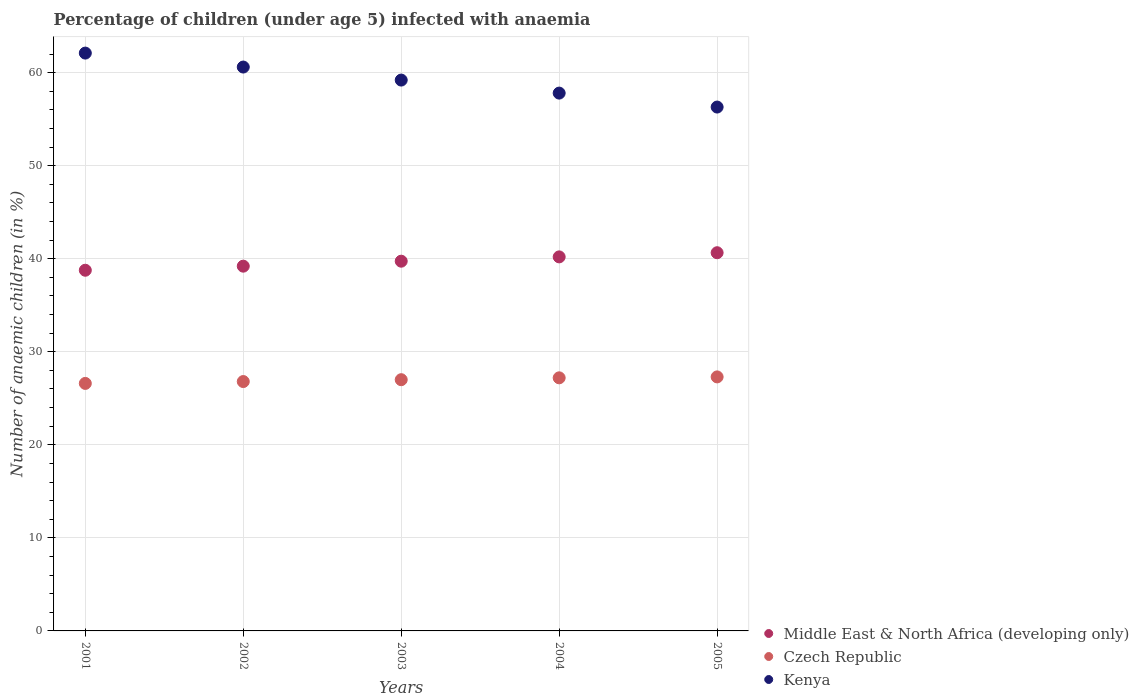Is the number of dotlines equal to the number of legend labels?
Provide a short and direct response. Yes. What is the percentage of children infected with anaemia in in Middle East & North Africa (developing only) in 2003?
Keep it short and to the point. 39.74. Across all years, what is the maximum percentage of children infected with anaemia in in Middle East & North Africa (developing only)?
Your response must be concise. 40.65. Across all years, what is the minimum percentage of children infected with anaemia in in Kenya?
Provide a short and direct response. 56.3. In which year was the percentage of children infected with anaemia in in Kenya minimum?
Provide a succinct answer. 2005. What is the total percentage of children infected with anaemia in in Middle East & North Africa (developing only) in the graph?
Make the answer very short. 198.54. What is the difference between the percentage of children infected with anaemia in in Czech Republic in 2001 and that in 2003?
Give a very brief answer. -0.4. What is the difference between the percentage of children infected with anaemia in in Kenya in 2002 and the percentage of children infected with anaemia in in Middle East & North Africa (developing only) in 2005?
Keep it short and to the point. 19.95. What is the average percentage of children infected with anaemia in in Czech Republic per year?
Offer a terse response. 26.98. In the year 2002, what is the difference between the percentage of children infected with anaemia in in Czech Republic and percentage of children infected with anaemia in in Middle East & North Africa (developing only)?
Provide a short and direct response. -12.4. In how many years, is the percentage of children infected with anaemia in in Czech Republic greater than 14 %?
Make the answer very short. 5. What is the ratio of the percentage of children infected with anaemia in in Middle East & North Africa (developing only) in 2002 to that in 2004?
Your answer should be very brief. 0.98. Is the percentage of children infected with anaemia in in Middle East & North Africa (developing only) in 2001 less than that in 2003?
Your answer should be compact. Yes. Is the difference between the percentage of children infected with anaemia in in Czech Republic in 2001 and 2004 greater than the difference between the percentage of children infected with anaemia in in Middle East & North Africa (developing only) in 2001 and 2004?
Provide a short and direct response. Yes. What is the difference between the highest and the second highest percentage of children infected with anaemia in in Czech Republic?
Give a very brief answer. 0.1. What is the difference between the highest and the lowest percentage of children infected with anaemia in in Middle East & North Africa (developing only)?
Your answer should be very brief. 1.88. In how many years, is the percentage of children infected with anaemia in in Middle East & North Africa (developing only) greater than the average percentage of children infected with anaemia in in Middle East & North Africa (developing only) taken over all years?
Ensure brevity in your answer.  3. Is the sum of the percentage of children infected with anaemia in in Middle East & North Africa (developing only) in 2002 and 2005 greater than the maximum percentage of children infected with anaemia in in Kenya across all years?
Provide a succinct answer. Yes. Does the percentage of children infected with anaemia in in Kenya monotonically increase over the years?
Offer a terse response. No. Is the percentage of children infected with anaemia in in Kenya strictly less than the percentage of children infected with anaemia in in Middle East & North Africa (developing only) over the years?
Your answer should be compact. No. How many years are there in the graph?
Offer a very short reply. 5. What is the difference between two consecutive major ticks on the Y-axis?
Offer a very short reply. 10. Does the graph contain any zero values?
Ensure brevity in your answer.  No. Does the graph contain grids?
Your response must be concise. Yes. Where does the legend appear in the graph?
Keep it short and to the point. Bottom right. How many legend labels are there?
Your response must be concise. 3. How are the legend labels stacked?
Your answer should be very brief. Vertical. What is the title of the graph?
Your answer should be compact. Percentage of children (under age 5) infected with anaemia. What is the label or title of the Y-axis?
Offer a very short reply. Number of anaemic children (in %). What is the Number of anaemic children (in %) of Middle East & North Africa (developing only) in 2001?
Your answer should be very brief. 38.76. What is the Number of anaemic children (in %) in Czech Republic in 2001?
Keep it short and to the point. 26.6. What is the Number of anaemic children (in %) in Kenya in 2001?
Your answer should be very brief. 62.1. What is the Number of anaemic children (in %) in Middle East & North Africa (developing only) in 2002?
Provide a short and direct response. 39.2. What is the Number of anaemic children (in %) of Czech Republic in 2002?
Your answer should be very brief. 26.8. What is the Number of anaemic children (in %) in Kenya in 2002?
Your answer should be very brief. 60.6. What is the Number of anaemic children (in %) of Middle East & North Africa (developing only) in 2003?
Provide a succinct answer. 39.74. What is the Number of anaemic children (in %) of Czech Republic in 2003?
Provide a succinct answer. 27. What is the Number of anaemic children (in %) of Kenya in 2003?
Keep it short and to the point. 59.2. What is the Number of anaemic children (in %) in Middle East & North Africa (developing only) in 2004?
Ensure brevity in your answer.  40.2. What is the Number of anaemic children (in %) of Czech Republic in 2004?
Provide a short and direct response. 27.2. What is the Number of anaemic children (in %) in Kenya in 2004?
Ensure brevity in your answer.  57.8. What is the Number of anaemic children (in %) of Middle East & North Africa (developing only) in 2005?
Provide a short and direct response. 40.65. What is the Number of anaemic children (in %) of Czech Republic in 2005?
Your answer should be compact. 27.3. What is the Number of anaemic children (in %) of Kenya in 2005?
Your response must be concise. 56.3. Across all years, what is the maximum Number of anaemic children (in %) of Middle East & North Africa (developing only)?
Provide a short and direct response. 40.65. Across all years, what is the maximum Number of anaemic children (in %) of Czech Republic?
Your answer should be compact. 27.3. Across all years, what is the maximum Number of anaemic children (in %) in Kenya?
Make the answer very short. 62.1. Across all years, what is the minimum Number of anaemic children (in %) of Middle East & North Africa (developing only)?
Keep it short and to the point. 38.76. Across all years, what is the minimum Number of anaemic children (in %) of Czech Republic?
Offer a very short reply. 26.6. Across all years, what is the minimum Number of anaemic children (in %) of Kenya?
Provide a succinct answer. 56.3. What is the total Number of anaemic children (in %) of Middle East & North Africa (developing only) in the graph?
Make the answer very short. 198.54. What is the total Number of anaemic children (in %) of Czech Republic in the graph?
Give a very brief answer. 134.9. What is the total Number of anaemic children (in %) in Kenya in the graph?
Ensure brevity in your answer.  296. What is the difference between the Number of anaemic children (in %) in Middle East & North Africa (developing only) in 2001 and that in 2002?
Offer a very short reply. -0.44. What is the difference between the Number of anaemic children (in %) of Kenya in 2001 and that in 2002?
Your answer should be compact. 1.5. What is the difference between the Number of anaemic children (in %) of Middle East & North Africa (developing only) in 2001 and that in 2003?
Provide a succinct answer. -0.97. What is the difference between the Number of anaemic children (in %) in Czech Republic in 2001 and that in 2003?
Provide a succinct answer. -0.4. What is the difference between the Number of anaemic children (in %) in Kenya in 2001 and that in 2003?
Ensure brevity in your answer.  2.9. What is the difference between the Number of anaemic children (in %) in Middle East & North Africa (developing only) in 2001 and that in 2004?
Your answer should be very brief. -1.44. What is the difference between the Number of anaemic children (in %) in Czech Republic in 2001 and that in 2004?
Provide a succinct answer. -0.6. What is the difference between the Number of anaemic children (in %) of Middle East & North Africa (developing only) in 2001 and that in 2005?
Offer a very short reply. -1.88. What is the difference between the Number of anaemic children (in %) of Czech Republic in 2001 and that in 2005?
Keep it short and to the point. -0.7. What is the difference between the Number of anaemic children (in %) in Kenya in 2001 and that in 2005?
Make the answer very short. 5.8. What is the difference between the Number of anaemic children (in %) in Middle East & North Africa (developing only) in 2002 and that in 2003?
Offer a terse response. -0.53. What is the difference between the Number of anaemic children (in %) of Middle East & North Africa (developing only) in 2002 and that in 2004?
Your answer should be very brief. -1. What is the difference between the Number of anaemic children (in %) of Czech Republic in 2002 and that in 2004?
Offer a very short reply. -0.4. What is the difference between the Number of anaemic children (in %) in Middle East & North Africa (developing only) in 2002 and that in 2005?
Give a very brief answer. -1.45. What is the difference between the Number of anaemic children (in %) in Middle East & North Africa (developing only) in 2003 and that in 2004?
Your response must be concise. -0.46. What is the difference between the Number of anaemic children (in %) of Czech Republic in 2003 and that in 2004?
Your answer should be very brief. -0.2. What is the difference between the Number of anaemic children (in %) in Middle East & North Africa (developing only) in 2003 and that in 2005?
Your response must be concise. -0.91. What is the difference between the Number of anaemic children (in %) in Kenya in 2003 and that in 2005?
Your answer should be very brief. 2.9. What is the difference between the Number of anaemic children (in %) of Middle East & North Africa (developing only) in 2004 and that in 2005?
Offer a terse response. -0.45. What is the difference between the Number of anaemic children (in %) of Middle East & North Africa (developing only) in 2001 and the Number of anaemic children (in %) of Czech Republic in 2002?
Your answer should be compact. 11.96. What is the difference between the Number of anaemic children (in %) in Middle East & North Africa (developing only) in 2001 and the Number of anaemic children (in %) in Kenya in 2002?
Ensure brevity in your answer.  -21.84. What is the difference between the Number of anaemic children (in %) in Czech Republic in 2001 and the Number of anaemic children (in %) in Kenya in 2002?
Give a very brief answer. -34. What is the difference between the Number of anaemic children (in %) in Middle East & North Africa (developing only) in 2001 and the Number of anaemic children (in %) in Czech Republic in 2003?
Your answer should be very brief. 11.76. What is the difference between the Number of anaemic children (in %) of Middle East & North Africa (developing only) in 2001 and the Number of anaemic children (in %) of Kenya in 2003?
Offer a very short reply. -20.44. What is the difference between the Number of anaemic children (in %) of Czech Republic in 2001 and the Number of anaemic children (in %) of Kenya in 2003?
Your response must be concise. -32.6. What is the difference between the Number of anaemic children (in %) of Middle East & North Africa (developing only) in 2001 and the Number of anaemic children (in %) of Czech Republic in 2004?
Offer a terse response. 11.56. What is the difference between the Number of anaemic children (in %) in Middle East & North Africa (developing only) in 2001 and the Number of anaemic children (in %) in Kenya in 2004?
Your answer should be very brief. -19.04. What is the difference between the Number of anaemic children (in %) in Czech Republic in 2001 and the Number of anaemic children (in %) in Kenya in 2004?
Provide a short and direct response. -31.2. What is the difference between the Number of anaemic children (in %) in Middle East & North Africa (developing only) in 2001 and the Number of anaemic children (in %) in Czech Republic in 2005?
Keep it short and to the point. 11.46. What is the difference between the Number of anaemic children (in %) of Middle East & North Africa (developing only) in 2001 and the Number of anaemic children (in %) of Kenya in 2005?
Provide a short and direct response. -17.54. What is the difference between the Number of anaemic children (in %) of Czech Republic in 2001 and the Number of anaemic children (in %) of Kenya in 2005?
Offer a terse response. -29.7. What is the difference between the Number of anaemic children (in %) of Middle East & North Africa (developing only) in 2002 and the Number of anaemic children (in %) of Czech Republic in 2003?
Offer a terse response. 12.2. What is the difference between the Number of anaemic children (in %) of Middle East & North Africa (developing only) in 2002 and the Number of anaemic children (in %) of Kenya in 2003?
Keep it short and to the point. -20. What is the difference between the Number of anaemic children (in %) of Czech Republic in 2002 and the Number of anaemic children (in %) of Kenya in 2003?
Ensure brevity in your answer.  -32.4. What is the difference between the Number of anaemic children (in %) of Middle East & North Africa (developing only) in 2002 and the Number of anaemic children (in %) of Czech Republic in 2004?
Give a very brief answer. 12. What is the difference between the Number of anaemic children (in %) of Middle East & North Africa (developing only) in 2002 and the Number of anaemic children (in %) of Kenya in 2004?
Offer a very short reply. -18.6. What is the difference between the Number of anaemic children (in %) in Czech Republic in 2002 and the Number of anaemic children (in %) in Kenya in 2004?
Offer a terse response. -31. What is the difference between the Number of anaemic children (in %) in Middle East & North Africa (developing only) in 2002 and the Number of anaemic children (in %) in Czech Republic in 2005?
Offer a terse response. 11.9. What is the difference between the Number of anaemic children (in %) of Middle East & North Africa (developing only) in 2002 and the Number of anaemic children (in %) of Kenya in 2005?
Keep it short and to the point. -17.1. What is the difference between the Number of anaemic children (in %) in Czech Republic in 2002 and the Number of anaemic children (in %) in Kenya in 2005?
Your answer should be very brief. -29.5. What is the difference between the Number of anaemic children (in %) of Middle East & North Africa (developing only) in 2003 and the Number of anaemic children (in %) of Czech Republic in 2004?
Make the answer very short. 12.54. What is the difference between the Number of anaemic children (in %) in Middle East & North Africa (developing only) in 2003 and the Number of anaemic children (in %) in Kenya in 2004?
Give a very brief answer. -18.06. What is the difference between the Number of anaemic children (in %) of Czech Republic in 2003 and the Number of anaemic children (in %) of Kenya in 2004?
Provide a short and direct response. -30.8. What is the difference between the Number of anaemic children (in %) of Middle East & North Africa (developing only) in 2003 and the Number of anaemic children (in %) of Czech Republic in 2005?
Offer a terse response. 12.44. What is the difference between the Number of anaemic children (in %) in Middle East & North Africa (developing only) in 2003 and the Number of anaemic children (in %) in Kenya in 2005?
Offer a very short reply. -16.56. What is the difference between the Number of anaemic children (in %) of Czech Republic in 2003 and the Number of anaemic children (in %) of Kenya in 2005?
Ensure brevity in your answer.  -29.3. What is the difference between the Number of anaemic children (in %) in Middle East & North Africa (developing only) in 2004 and the Number of anaemic children (in %) in Czech Republic in 2005?
Make the answer very short. 12.9. What is the difference between the Number of anaemic children (in %) of Middle East & North Africa (developing only) in 2004 and the Number of anaemic children (in %) of Kenya in 2005?
Offer a terse response. -16.1. What is the difference between the Number of anaemic children (in %) of Czech Republic in 2004 and the Number of anaemic children (in %) of Kenya in 2005?
Offer a very short reply. -29.1. What is the average Number of anaemic children (in %) of Middle East & North Africa (developing only) per year?
Your response must be concise. 39.71. What is the average Number of anaemic children (in %) in Czech Republic per year?
Provide a short and direct response. 26.98. What is the average Number of anaemic children (in %) in Kenya per year?
Keep it short and to the point. 59.2. In the year 2001, what is the difference between the Number of anaemic children (in %) of Middle East & North Africa (developing only) and Number of anaemic children (in %) of Czech Republic?
Ensure brevity in your answer.  12.16. In the year 2001, what is the difference between the Number of anaemic children (in %) of Middle East & North Africa (developing only) and Number of anaemic children (in %) of Kenya?
Provide a short and direct response. -23.34. In the year 2001, what is the difference between the Number of anaemic children (in %) in Czech Republic and Number of anaemic children (in %) in Kenya?
Make the answer very short. -35.5. In the year 2002, what is the difference between the Number of anaemic children (in %) of Middle East & North Africa (developing only) and Number of anaemic children (in %) of Czech Republic?
Offer a terse response. 12.4. In the year 2002, what is the difference between the Number of anaemic children (in %) of Middle East & North Africa (developing only) and Number of anaemic children (in %) of Kenya?
Offer a terse response. -21.4. In the year 2002, what is the difference between the Number of anaemic children (in %) of Czech Republic and Number of anaemic children (in %) of Kenya?
Ensure brevity in your answer.  -33.8. In the year 2003, what is the difference between the Number of anaemic children (in %) in Middle East & North Africa (developing only) and Number of anaemic children (in %) in Czech Republic?
Give a very brief answer. 12.74. In the year 2003, what is the difference between the Number of anaemic children (in %) in Middle East & North Africa (developing only) and Number of anaemic children (in %) in Kenya?
Make the answer very short. -19.46. In the year 2003, what is the difference between the Number of anaemic children (in %) of Czech Republic and Number of anaemic children (in %) of Kenya?
Make the answer very short. -32.2. In the year 2004, what is the difference between the Number of anaemic children (in %) of Middle East & North Africa (developing only) and Number of anaemic children (in %) of Czech Republic?
Your response must be concise. 13. In the year 2004, what is the difference between the Number of anaemic children (in %) in Middle East & North Africa (developing only) and Number of anaemic children (in %) in Kenya?
Your answer should be very brief. -17.6. In the year 2004, what is the difference between the Number of anaemic children (in %) of Czech Republic and Number of anaemic children (in %) of Kenya?
Your response must be concise. -30.6. In the year 2005, what is the difference between the Number of anaemic children (in %) of Middle East & North Africa (developing only) and Number of anaemic children (in %) of Czech Republic?
Give a very brief answer. 13.35. In the year 2005, what is the difference between the Number of anaemic children (in %) of Middle East & North Africa (developing only) and Number of anaemic children (in %) of Kenya?
Ensure brevity in your answer.  -15.65. What is the ratio of the Number of anaemic children (in %) in Middle East & North Africa (developing only) in 2001 to that in 2002?
Keep it short and to the point. 0.99. What is the ratio of the Number of anaemic children (in %) of Kenya in 2001 to that in 2002?
Make the answer very short. 1.02. What is the ratio of the Number of anaemic children (in %) in Middle East & North Africa (developing only) in 2001 to that in 2003?
Provide a short and direct response. 0.98. What is the ratio of the Number of anaemic children (in %) of Czech Republic in 2001 to that in 2003?
Make the answer very short. 0.99. What is the ratio of the Number of anaemic children (in %) of Kenya in 2001 to that in 2003?
Provide a succinct answer. 1.05. What is the ratio of the Number of anaemic children (in %) in Czech Republic in 2001 to that in 2004?
Keep it short and to the point. 0.98. What is the ratio of the Number of anaemic children (in %) of Kenya in 2001 to that in 2004?
Ensure brevity in your answer.  1.07. What is the ratio of the Number of anaemic children (in %) in Middle East & North Africa (developing only) in 2001 to that in 2005?
Keep it short and to the point. 0.95. What is the ratio of the Number of anaemic children (in %) in Czech Republic in 2001 to that in 2005?
Make the answer very short. 0.97. What is the ratio of the Number of anaemic children (in %) of Kenya in 2001 to that in 2005?
Keep it short and to the point. 1.1. What is the ratio of the Number of anaemic children (in %) in Middle East & North Africa (developing only) in 2002 to that in 2003?
Provide a succinct answer. 0.99. What is the ratio of the Number of anaemic children (in %) in Czech Republic in 2002 to that in 2003?
Give a very brief answer. 0.99. What is the ratio of the Number of anaemic children (in %) of Kenya in 2002 to that in 2003?
Ensure brevity in your answer.  1.02. What is the ratio of the Number of anaemic children (in %) in Middle East & North Africa (developing only) in 2002 to that in 2004?
Offer a terse response. 0.98. What is the ratio of the Number of anaemic children (in %) in Kenya in 2002 to that in 2004?
Your answer should be compact. 1.05. What is the ratio of the Number of anaemic children (in %) of Middle East & North Africa (developing only) in 2002 to that in 2005?
Your response must be concise. 0.96. What is the ratio of the Number of anaemic children (in %) in Czech Republic in 2002 to that in 2005?
Provide a succinct answer. 0.98. What is the ratio of the Number of anaemic children (in %) in Kenya in 2002 to that in 2005?
Your answer should be very brief. 1.08. What is the ratio of the Number of anaemic children (in %) in Kenya in 2003 to that in 2004?
Provide a short and direct response. 1.02. What is the ratio of the Number of anaemic children (in %) in Middle East & North Africa (developing only) in 2003 to that in 2005?
Give a very brief answer. 0.98. What is the ratio of the Number of anaemic children (in %) in Kenya in 2003 to that in 2005?
Keep it short and to the point. 1.05. What is the ratio of the Number of anaemic children (in %) in Czech Republic in 2004 to that in 2005?
Provide a succinct answer. 1. What is the ratio of the Number of anaemic children (in %) of Kenya in 2004 to that in 2005?
Provide a short and direct response. 1.03. What is the difference between the highest and the second highest Number of anaemic children (in %) in Middle East & North Africa (developing only)?
Ensure brevity in your answer.  0.45. What is the difference between the highest and the second highest Number of anaemic children (in %) of Czech Republic?
Offer a terse response. 0.1. What is the difference between the highest and the lowest Number of anaemic children (in %) of Middle East & North Africa (developing only)?
Make the answer very short. 1.88. 